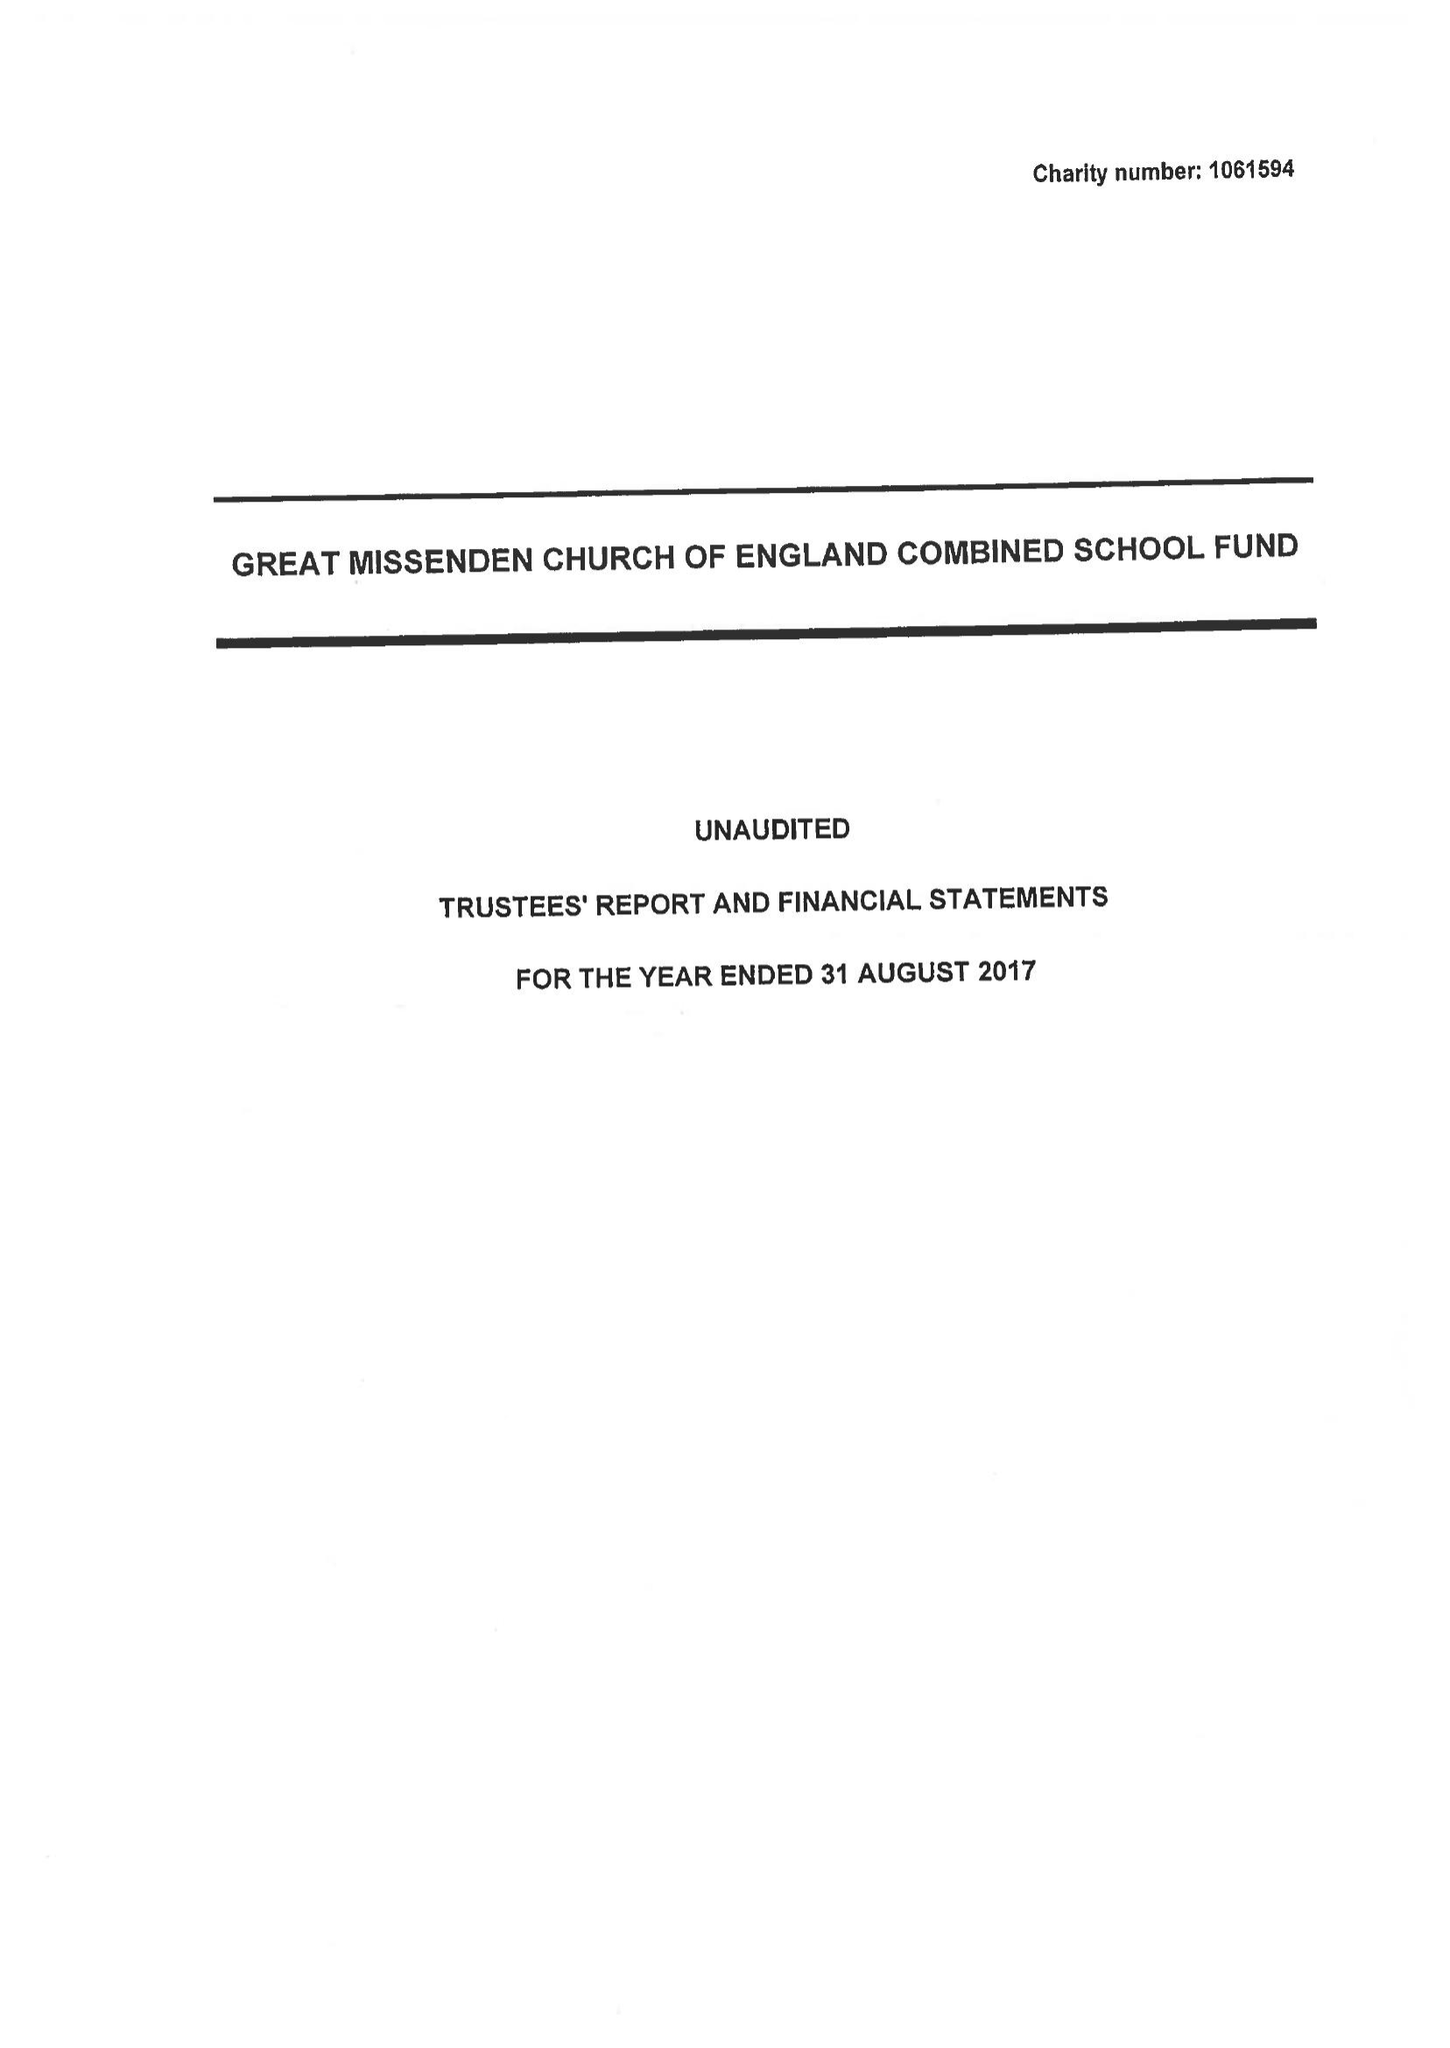What is the value for the address__street_line?
Answer the question using a single word or phrase. CHURCH STREET 